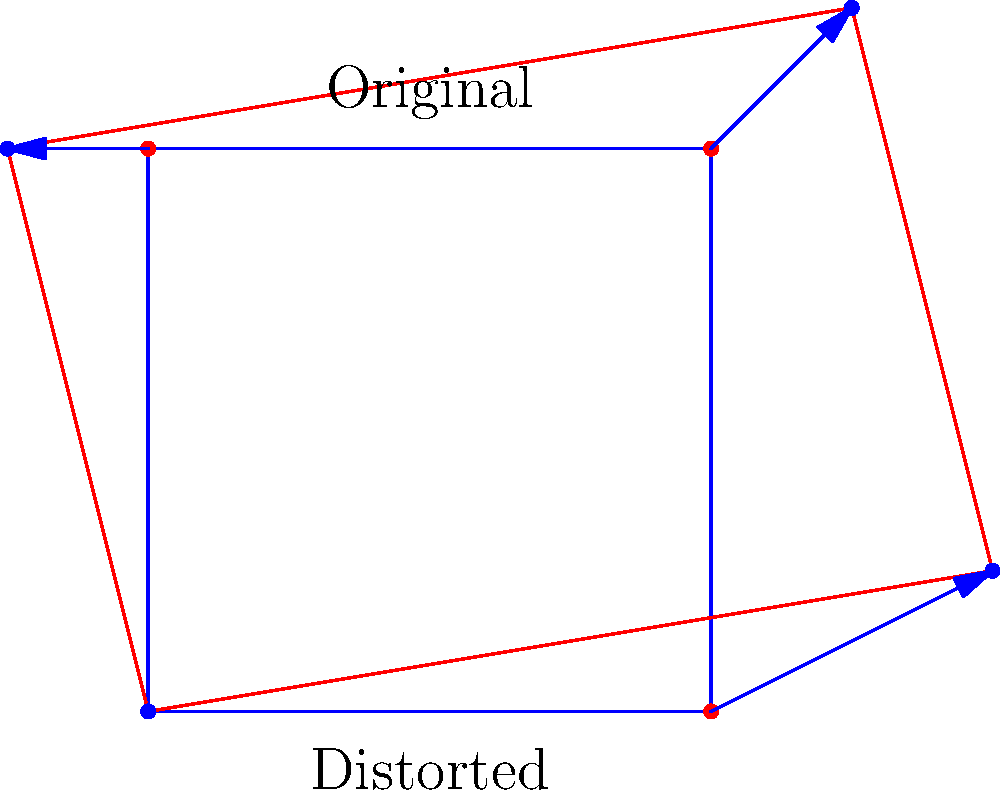Given the distorted aerial image shown in red and the original image outline in blue, determine the affine transformation matrix that would correct the distortion. Assume the control points are at the corners of the images, starting from the bottom-left corner and moving clockwise. Express your answer as a 3x3 matrix. To find the affine transformation matrix, we need to follow these steps:

1. Identify the control points in both the original and distorted images:
   Original: $(0,0)$, $(2,0)$, $(2,2)$, $(0,2)$
   Distorted: $(0,0)$, $(3,0.5)$, $(2.5,2.5)$, $(-0.5,2)$

2. Set up the system of equations for the affine transformation:
   $\begin{bmatrix} x' \\ y' \\ 1 \end{bmatrix} = \begin{bmatrix} a & b & c \\ d & e & f \\ 0 & 0 & 1 \end{bmatrix} \begin{bmatrix} x \\ y \\ 1 \end{bmatrix}$

3. Use the control points to create a system of linear equations:
   $\begin{align}
   0 &= 0a + 0b + c \\
   0 &= 0d + 0e + f \\
   3 &= 2a + 0b + c \\
   0.5 &= 2d + 0e + f \\
   2.5 &= 2a + 2b + c \\
   2.5 &= 2d + 2e + f \\
   -0.5 &= 0a + 2b + c \\
   2 &= 0d + 2e + f
   \end{align}$

4. Solve the system of equations:
   $\begin{align}
   a &= 1.5 \\
   b &= -0.25 \\
   c &= 0 \\
   d &= 0.25 \\
   e &= 1 \\
   f &= 0
   \end{align}$

5. Construct the affine transformation matrix:
   $\begin{bmatrix}
   1.5 & -0.25 & 0 \\
   0.25 & 1 & 0 \\
   0 & 0 & 1
   \end{bmatrix}$

This matrix represents the transformation from the distorted image to the original image.
Answer: $$\begin{bmatrix}
1.5 & -0.25 & 0 \\
0.25 & 1 & 0 \\
0 & 0 & 1
\end{bmatrix}$$ 